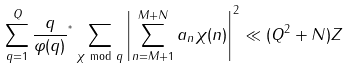Convert formula to latex. <formula><loc_0><loc_0><loc_500><loc_500>\sum _ { q = 1 } ^ { Q } \frac { q } { \varphi ( q ) } { ^ { ^ { * } } } \sum _ { \chi \, \bmod { \, q } } \left | \sum _ { n = M + 1 } ^ { M + N } a _ { n } \chi ( n ) \right | ^ { 2 } \ll ( Q ^ { 2 } + N ) Z</formula> 